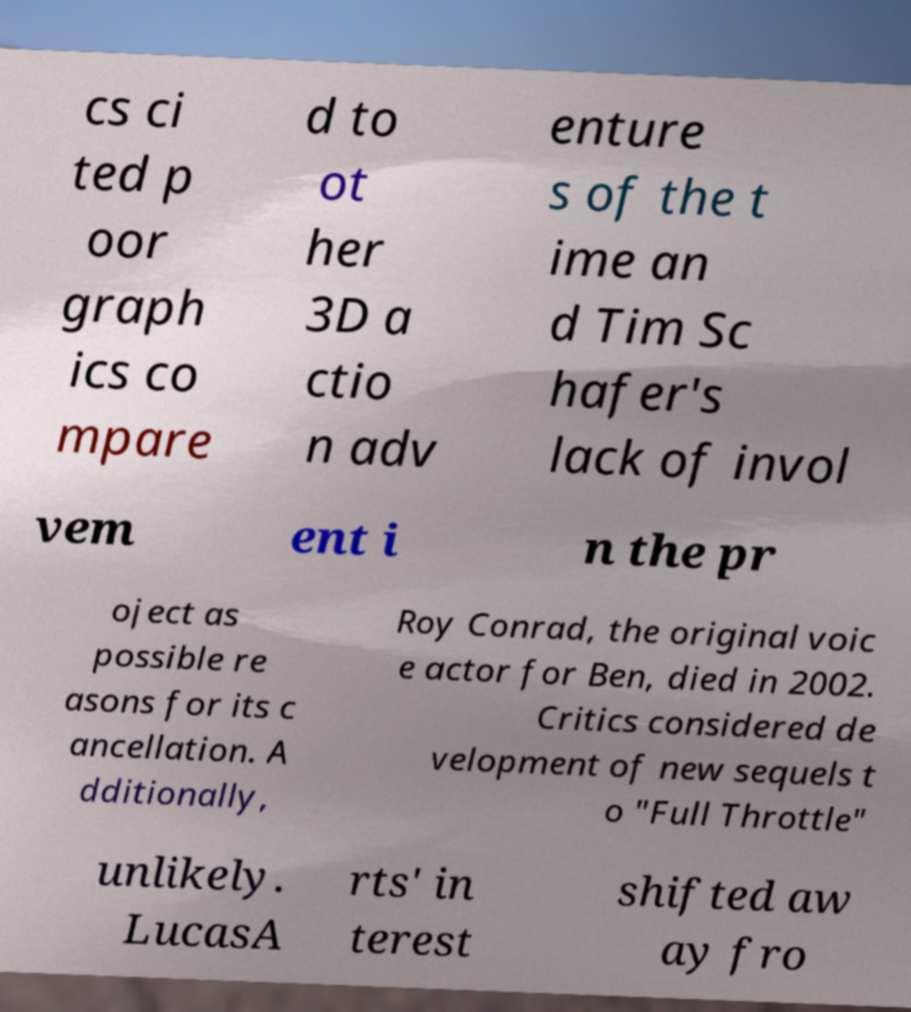There's text embedded in this image that I need extracted. Can you transcribe it verbatim? cs ci ted p oor graph ics co mpare d to ot her 3D a ctio n adv enture s of the t ime an d Tim Sc hafer's lack of invol vem ent i n the pr oject as possible re asons for its c ancellation. A dditionally, Roy Conrad, the original voic e actor for Ben, died in 2002. Critics considered de velopment of new sequels t o "Full Throttle" unlikely. LucasA rts' in terest shifted aw ay fro 